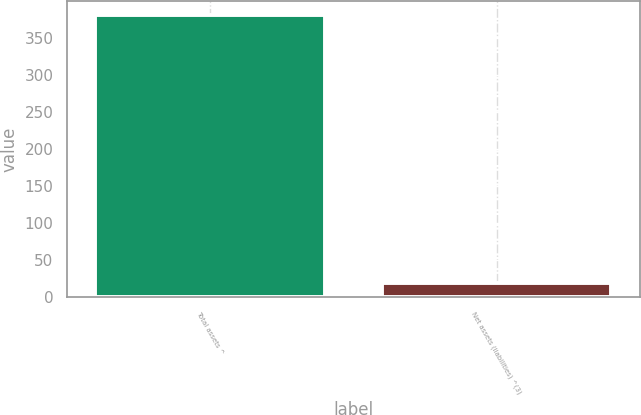Convert chart. <chart><loc_0><loc_0><loc_500><loc_500><bar_chart><fcel>Total assets ^<fcel>Net assets (liabilities) ^(3)<nl><fcel>380<fcel>19<nl></chart> 